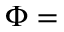<formula> <loc_0><loc_0><loc_500><loc_500>\Phi =</formula> 